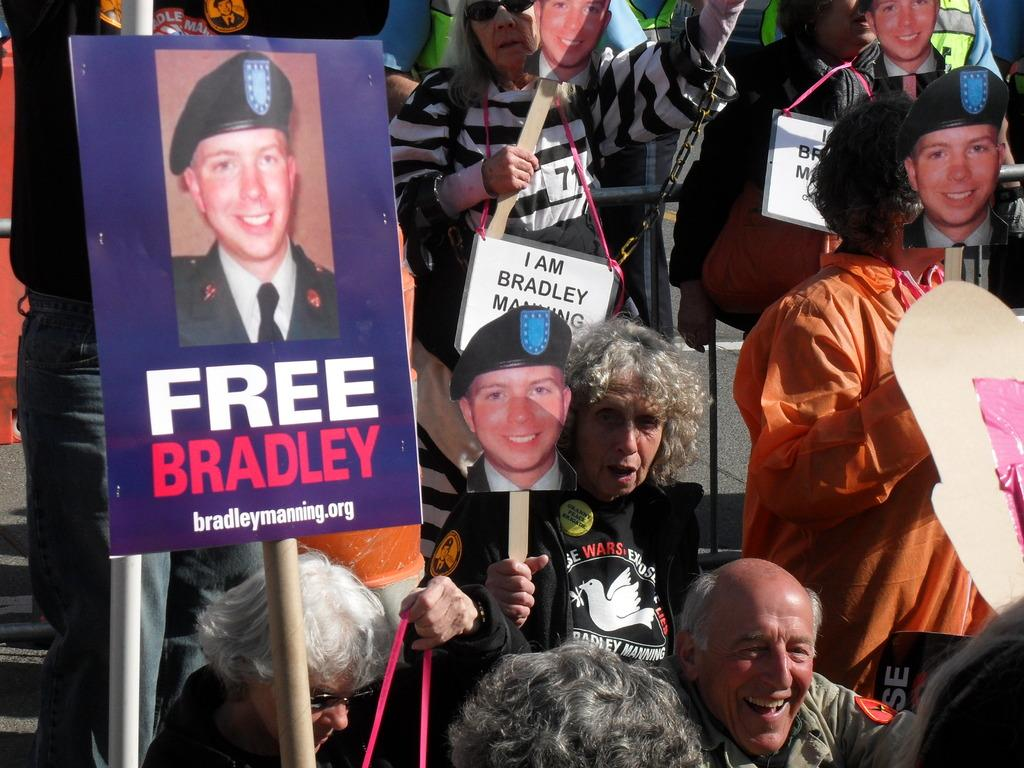How many people are in the image? There is a group of people in the image, but the exact number is not specified. What are the people standing on in the image? The people are standing on a path in the image. What are some people holding in the image? Some people are holding sticks with boards in the image. What type of hammer can be seen in the hands of the people in the image? There is no hammer present in the image; the people are holding sticks with boards. Does the existence of the people in the image prove the existence of extraterrestrial life? The presence of people in the image does not prove the existence of extraterrestrial life, as they are likely human beings. 